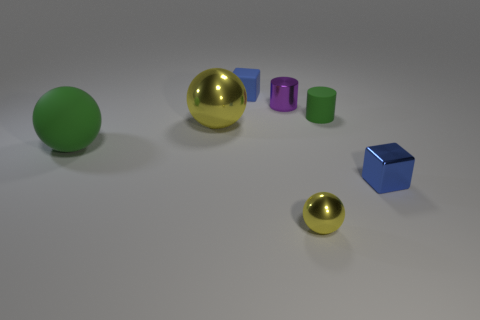What material is the blue cube in front of the tiny cylinder that is behind the tiny cylinder on the right side of the tiny purple cylinder made of? metal 